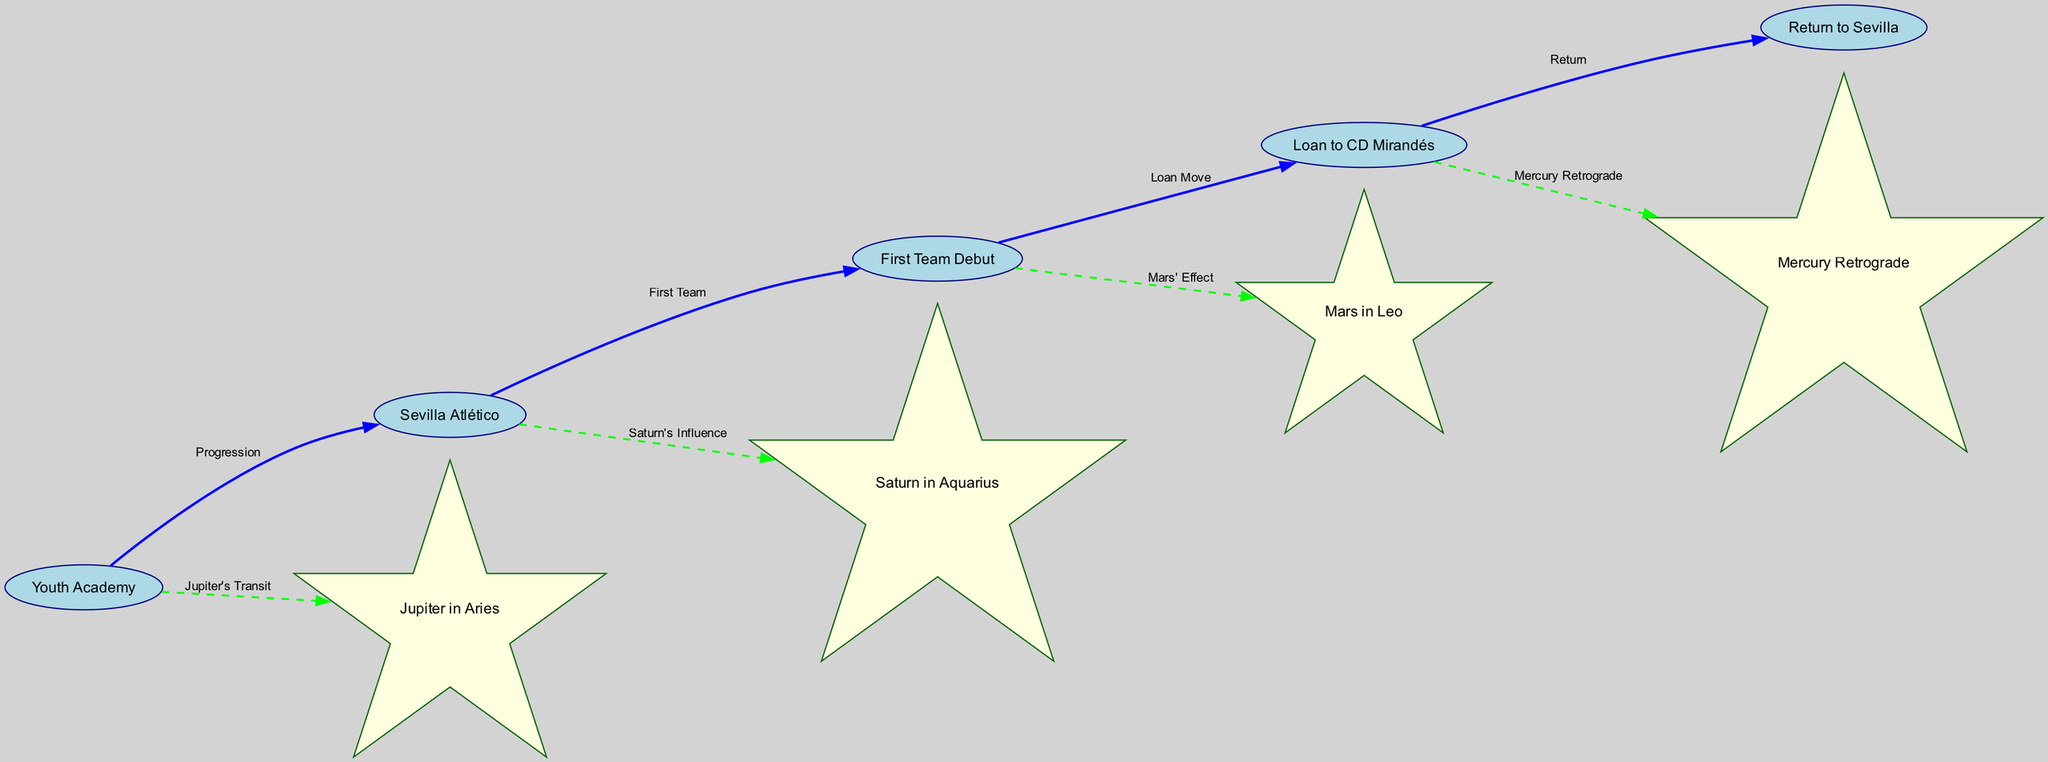What are the different career phases shown in the diagram? The diagram displays five career phases: Youth Academy, Sevilla Atlético, First Team Debut, Loan to CD Mirandés, and Return to Sevilla.
Answer: Youth Academy, Sevilla Atlético, First Team Debut, Loan to CD Mirandés, Return to Sevilla How many planetary transits are represented in the diagram? The diagram includes four planetary transits: Jupiter in Aries, Saturn in Aquarius, Mars in Leo, and Mercury Retrograde.
Answer: 4 What relationship connects the "Youth Academy" to "Sevilla Atlético"? The relationship connecting these two nodes is labeled "Progression." This indicates a movement or advancement from the Youth Academy to Sevilla Atlético.
Answer: Progression Which planetary transit is linked to the "First Team Debut"? The "First Team Debut" node is connected to the planetary transit labeled "Mars in Leo," indicating an astrological influence at this phase in Luismi's career.
Answer: Mars in Leo What is the connection type between "Loan to CD Mirandés" and "Return to Sevilla"? The connection type is labeled "Return," suggesting that it is a move back to Sevilla after the loan period.
Answer: Return Which phase directly follows "First Team Debut" in Luismi's career? The "Loan to CD Mirandés" phase directly follows the "First Team Debut," indicating a career progression after debuting for the first team.
Answer: Loan to CD Mirandés How does "Saturn's Influence" relate to Luismi's career? "Saturn's Influence" is connected to the Sevilla Atlético phase, indicating that astrological factors associated with Saturn impacted this transition in Luismi's career.
Answer: Sevilla Atlético Which career phase is associated with "Mercury Retrograde"? The "Loan to CD Mirandés" phase is associated with "Mercury Retrograde," suggesting that this astrological phenomenon played a role during that part of Luismi's career.
Answer: Loan to CD Mirandés What is the overall theme of the diagram? The overall theme compares Luismi Cruz's career phases with planetary transits, emphasizing how astrology may parallel or influence his sporting journey.
Answer: Comparative analysis of career and astrology 